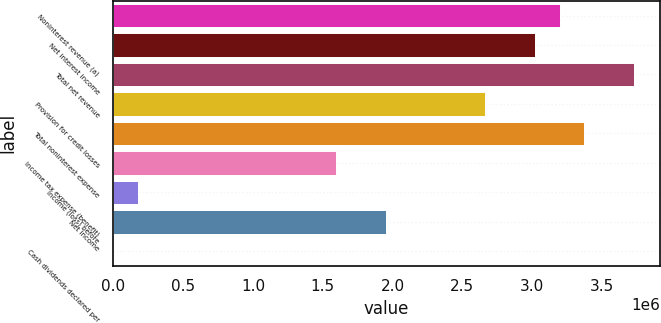<chart> <loc_0><loc_0><loc_500><loc_500><bar_chart><fcel>Noninterest revenue (a)<fcel>Net interest income<fcel>Total net revenue<fcel>Provision for credit losses<fcel>Total noninterest expense<fcel>Income tax expense (benefit)<fcel>Income (loss) before<fcel>Net income<fcel>Cash dividends declared per<nl><fcel>3.19621e+06<fcel>3.01864e+06<fcel>3.72891e+06<fcel>2.6635e+06<fcel>3.37377e+06<fcel>1.5981e+06<fcel>177567<fcel>1.95324e+06<fcel>0.38<nl></chart> 